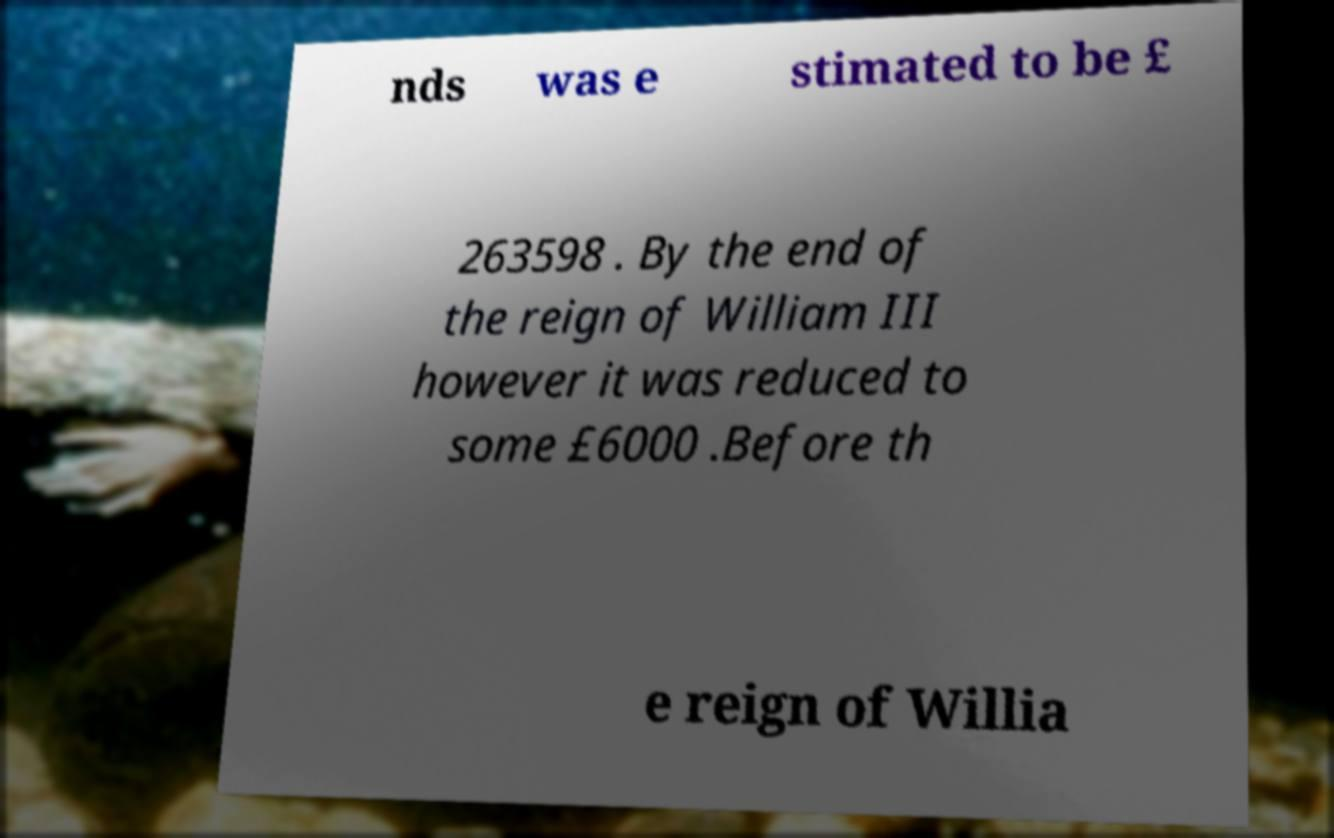There's text embedded in this image that I need extracted. Can you transcribe it verbatim? nds was e stimated to be £ 263598 . By the end of the reign of William III however it was reduced to some £6000 .Before th e reign of Willia 